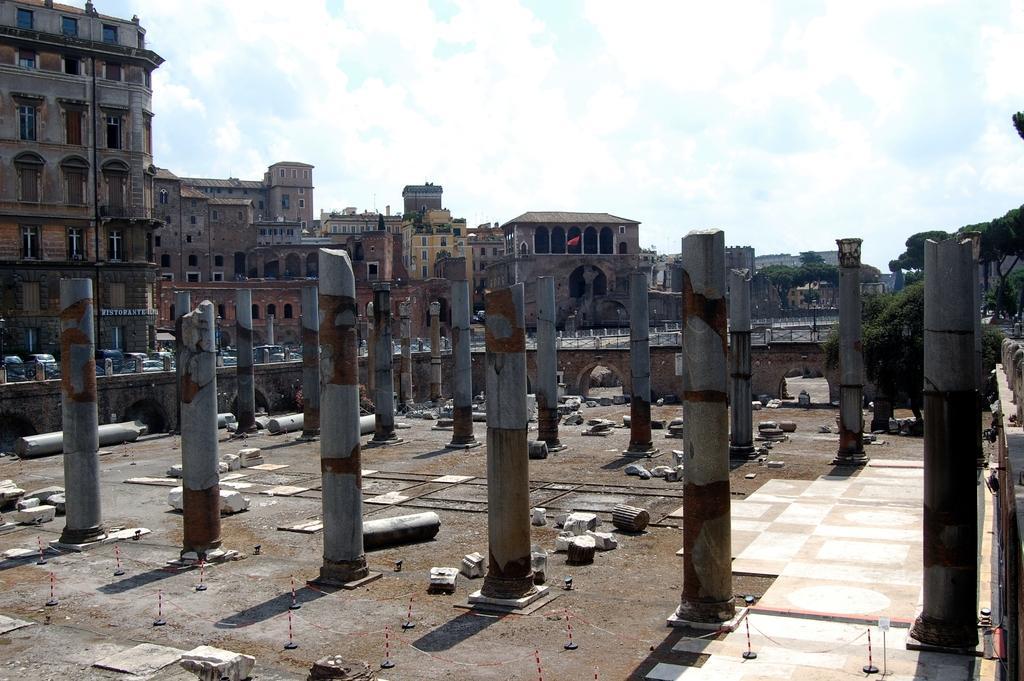Could you give a brief overview of what you see in this image? Here I can see few poles on the ground. At the bottom of the image there are some broken parts of these poles. In the background, I can see few cars on the road, buildings and some trees. At the top I can see the sky. 